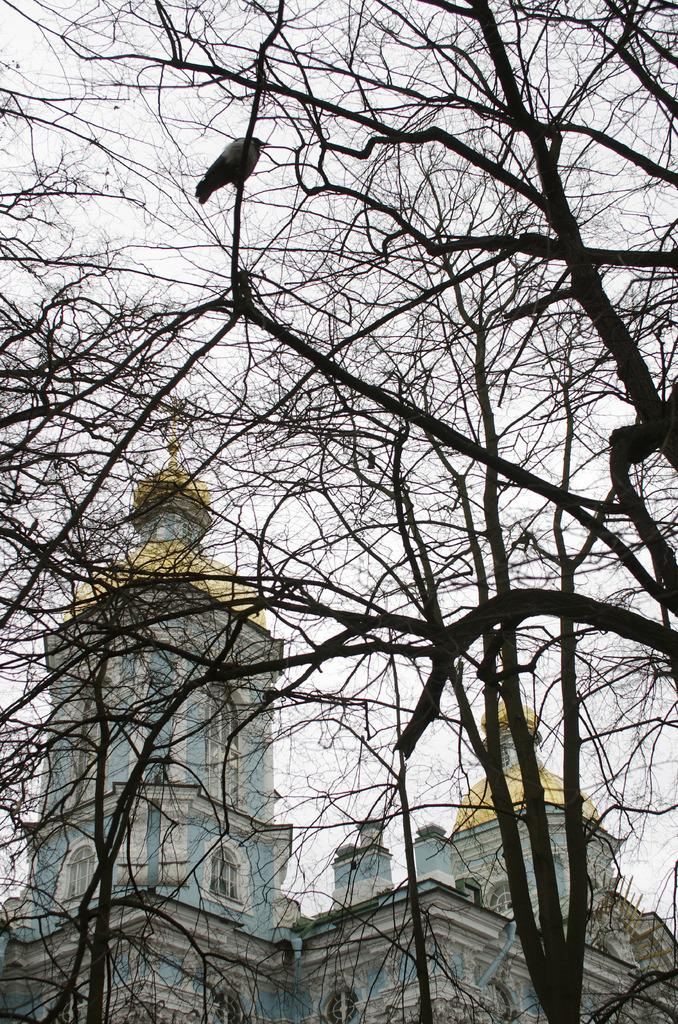What type of vegetation can be seen in the image? There are trees in the image. Is there any wildlife visible in the image? Yes, there is a bird on a tree branch in the image. What can be seen in the background of the image? There is a building and the sky visible in the background of the image. What type of cherry is the dog eating in the image? There is no dog or cherry present in the image. How does the tramp contribute to the image? There is no tramp present in the image. 